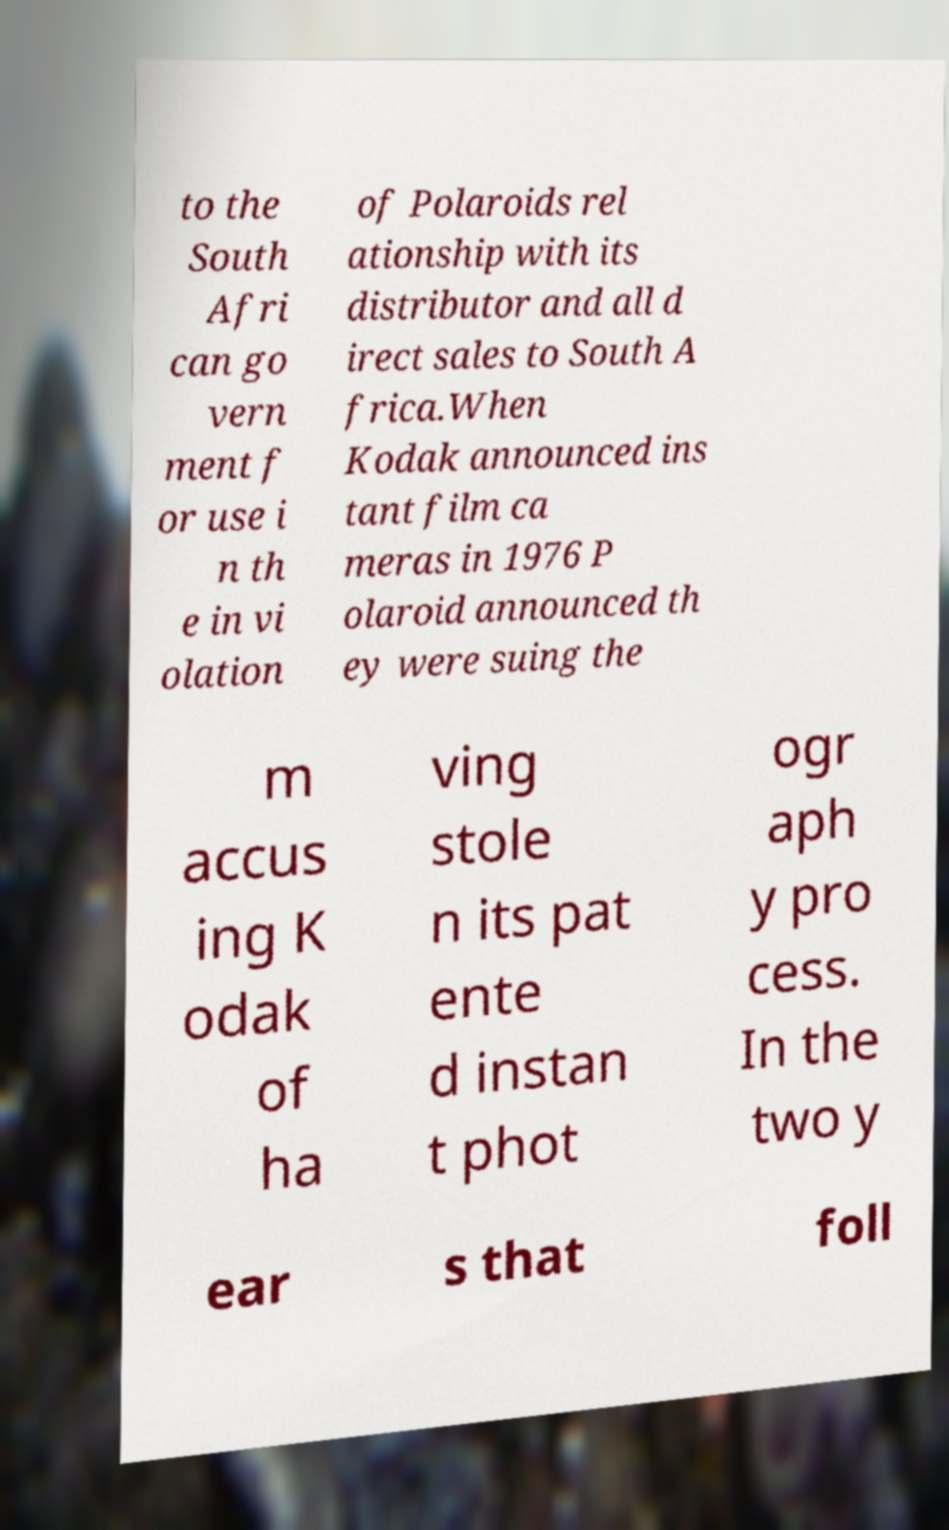Could you assist in decoding the text presented in this image and type it out clearly? to the South Afri can go vern ment f or use i n th e in vi olation of Polaroids rel ationship with its distributor and all d irect sales to South A frica.When Kodak announced ins tant film ca meras in 1976 P olaroid announced th ey were suing the m accus ing K odak of ha ving stole n its pat ente d instan t phot ogr aph y pro cess. In the two y ear s that foll 